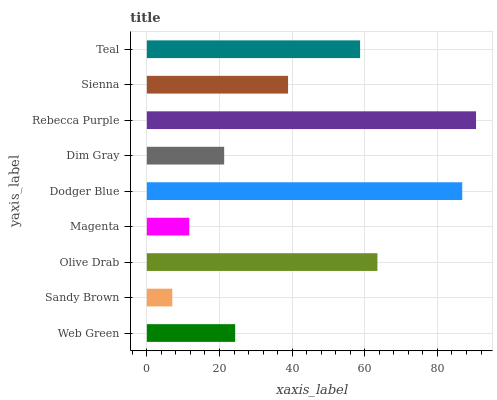Is Sandy Brown the minimum?
Answer yes or no. Yes. Is Rebecca Purple the maximum?
Answer yes or no. Yes. Is Olive Drab the minimum?
Answer yes or no. No. Is Olive Drab the maximum?
Answer yes or no. No. Is Olive Drab greater than Sandy Brown?
Answer yes or no. Yes. Is Sandy Brown less than Olive Drab?
Answer yes or no. Yes. Is Sandy Brown greater than Olive Drab?
Answer yes or no. No. Is Olive Drab less than Sandy Brown?
Answer yes or no. No. Is Sienna the high median?
Answer yes or no. Yes. Is Sienna the low median?
Answer yes or no. Yes. Is Sandy Brown the high median?
Answer yes or no. No. Is Sandy Brown the low median?
Answer yes or no. No. 